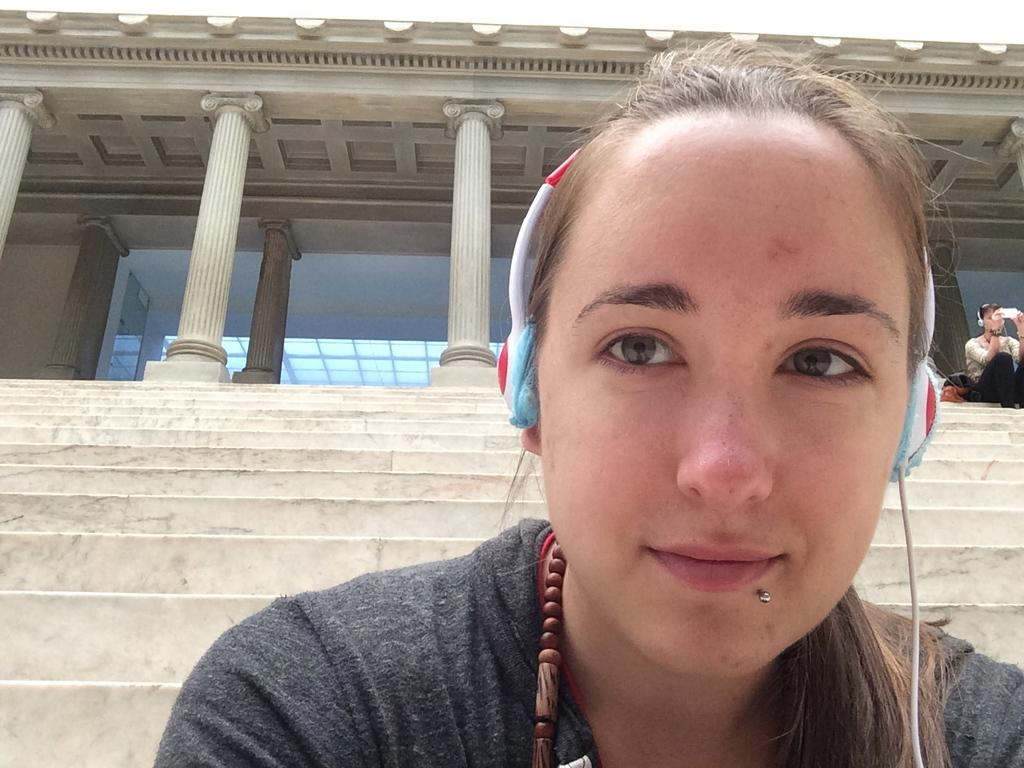What is the woman in the foreground of the picture doing? The woman is wearing headphones in the foreground of the picture. Where is the other person in the image located? There is a person sitting on the staircase on the right side of the image. What can be seen at the top of the image? There is a building at the top of the image. What type of mass is being sorted by the woman in the image? There is no indication in the image that the woman is sorting any mass; she is simply wearing headphones. 